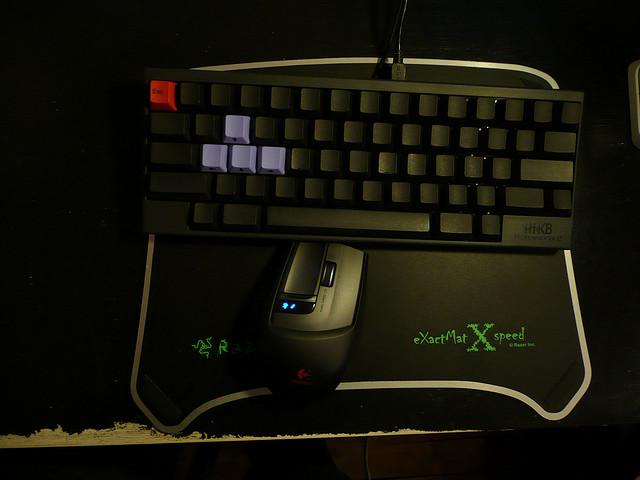What color is the keyboard?
Keep it brief. Black. Why are those four keys blue?
Keep it brief. Arrow controller. Is this a full size keyboard?
Short answer required. No. What is the red key?
Answer briefly. Esc. What color is the line across the picture?
Be succinct. White. What is the name on the mousepad?
Quick response, please. Exactmat x speed. Is this picture taken outside?
Quick response, please. No. What does the apple represent?
Write a very short answer. Logo. Is this graffiti?
Answer briefly. No. Is this clean or dirty?
Give a very brief answer. Clean. What is on the keyboard?
Answer briefly. Keys. 